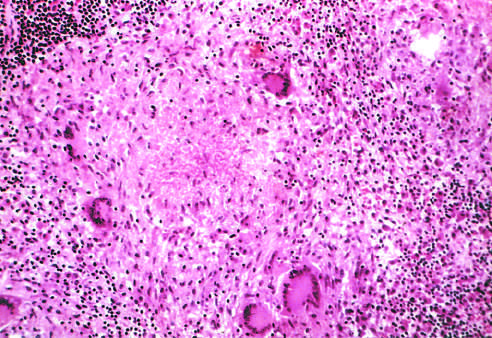what is an area of central necrosis surrounded by?
Answer the question using a single word or phrase. Multiple multinucleate giant cells 